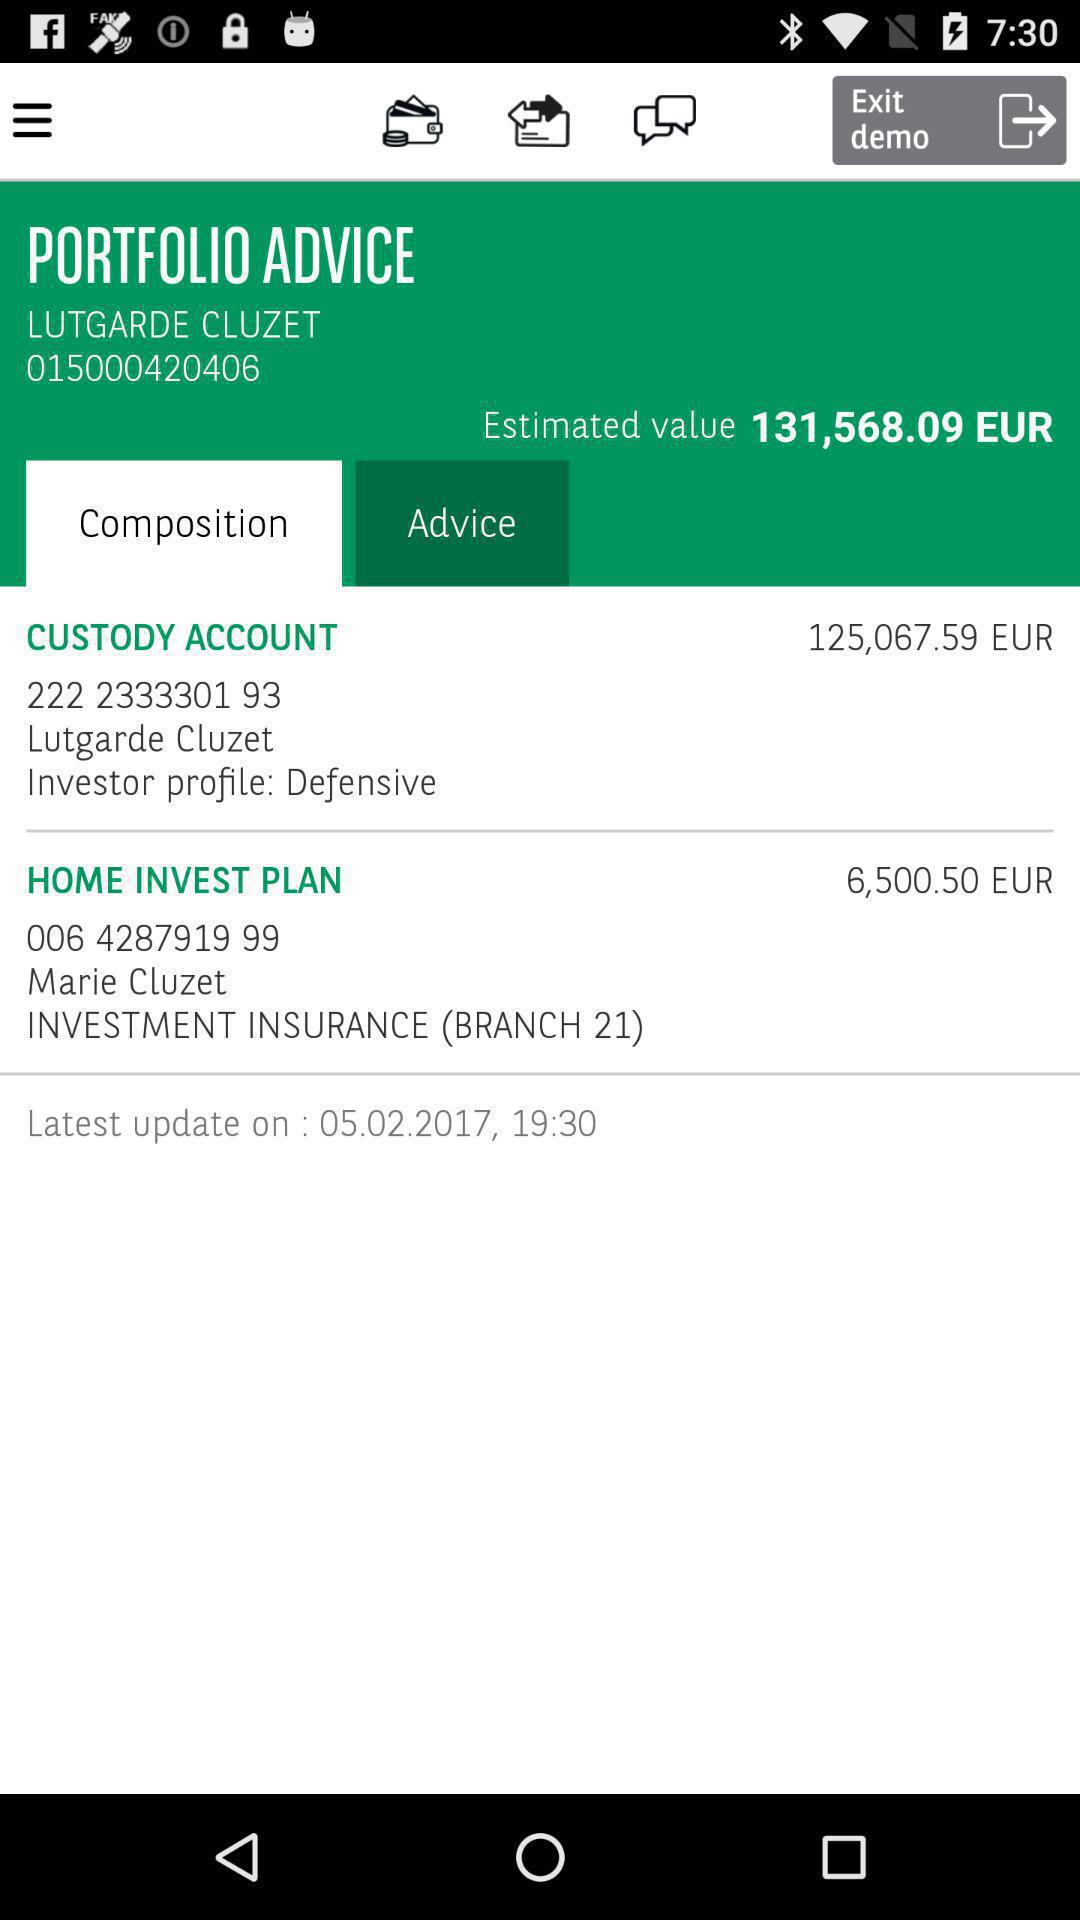Which tab is selected? The selected tab is "Composition". 